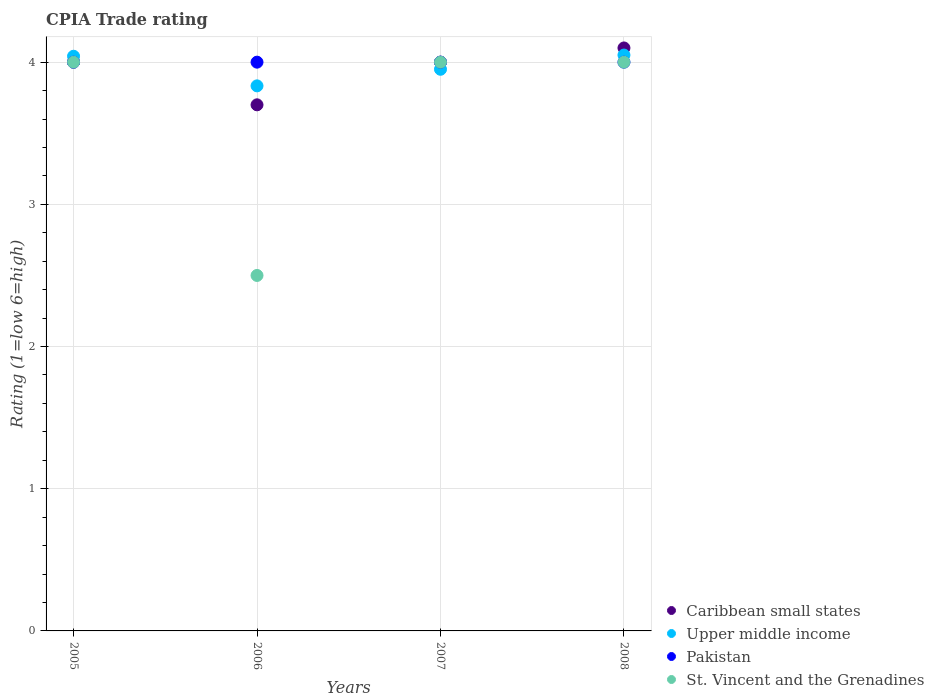How many different coloured dotlines are there?
Make the answer very short. 4. Across all years, what is the minimum CPIA rating in St. Vincent and the Grenadines?
Provide a succinct answer. 2.5. What is the total CPIA rating in Caribbean small states in the graph?
Your answer should be very brief. 15.8. What is the difference between the CPIA rating in St. Vincent and the Grenadines in 2006 and that in 2008?
Offer a very short reply. -1.5. What is the difference between the CPIA rating in Upper middle income in 2007 and the CPIA rating in St. Vincent and the Grenadines in 2008?
Your answer should be compact. -0.05. What is the average CPIA rating in St. Vincent and the Grenadines per year?
Your answer should be compact. 3.62. In the year 2006, what is the difference between the CPIA rating in Pakistan and CPIA rating in Caribbean small states?
Your response must be concise. 0.3. In how many years, is the CPIA rating in Upper middle income greater than 0.4?
Your answer should be compact. 4. Is the CPIA rating in Pakistan in 2006 less than that in 2008?
Your answer should be compact. No. What is the difference between the highest and the second highest CPIA rating in Upper middle income?
Ensure brevity in your answer.  0.01. What is the difference between the highest and the lowest CPIA rating in Caribbean small states?
Keep it short and to the point. 0.4. Is it the case that in every year, the sum of the CPIA rating in Pakistan and CPIA rating in Upper middle income  is greater than the sum of CPIA rating in St. Vincent and the Grenadines and CPIA rating in Caribbean small states?
Make the answer very short. Yes. Is it the case that in every year, the sum of the CPIA rating in Pakistan and CPIA rating in Caribbean small states  is greater than the CPIA rating in St. Vincent and the Grenadines?
Keep it short and to the point. Yes. Is the CPIA rating in St. Vincent and the Grenadines strictly greater than the CPIA rating in Caribbean small states over the years?
Your answer should be compact. No. How many dotlines are there?
Give a very brief answer. 4. How many years are there in the graph?
Offer a terse response. 4. What is the difference between two consecutive major ticks on the Y-axis?
Your answer should be very brief. 1. Are the values on the major ticks of Y-axis written in scientific E-notation?
Give a very brief answer. No. Does the graph contain any zero values?
Provide a short and direct response. No. Where does the legend appear in the graph?
Offer a terse response. Bottom right. What is the title of the graph?
Your answer should be compact. CPIA Trade rating. Does "Switzerland" appear as one of the legend labels in the graph?
Provide a succinct answer. No. What is the label or title of the X-axis?
Make the answer very short. Years. What is the Rating (1=low 6=high) of Caribbean small states in 2005?
Offer a very short reply. 4. What is the Rating (1=low 6=high) of Upper middle income in 2005?
Offer a terse response. 4.04. What is the Rating (1=low 6=high) in St. Vincent and the Grenadines in 2005?
Keep it short and to the point. 4. What is the Rating (1=low 6=high) of Caribbean small states in 2006?
Your answer should be very brief. 3.7. What is the Rating (1=low 6=high) in Upper middle income in 2006?
Provide a succinct answer. 3.83. What is the Rating (1=low 6=high) in Upper middle income in 2007?
Provide a short and direct response. 3.95. What is the Rating (1=low 6=high) in Pakistan in 2007?
Provide a succinct answer. 4. What is the Rating (1=low 6=high) of St. Vincent and the Grenadines in 2007?
Your answer should be compact. 4. What is the Rating (1=low 6=high) in Caribbean small states in 2008?
Provide a succinct answer. 4.1. What is the Rating (1=low 6=high) in Upper middle income in 2008?
Provide a short and direct response. 4.05. What is the Rating (1=low 6=high) in Pakistan in 2008?
Your response must be concise. 4. What is the Rating (1=low 6=high) in St. Vincent and the Grenadines in 2008?
Keep it short and to the point. 4. Across all years, what is the maximum Rating (1=low 6=high) in Caribbean small states?
Give a very brief answer. 4.1. Across all years, what is the maximum Rating (1=low 6=high) of Upper middle income?
Give a very brief answer. 4.05. Across all years, what is the maximum Rating (1=low 6=high) of Pakistan?
Offer a very short reply. 4. Across all years, what is the minimum Rating (1=low 6=high) in Caribbean small states?
Provide a succinct answer. 3.7. Across all years, what is the minimum Rating (1=low 6=high) in Upper middle income?
Your answer should be compact. 3.83. Across all years, what is the minimum Rating (1=low 6=high) of Pakistan?
Your response must be concise. 4. What is the total Rating (1=low 6=high) of Upper middle income in the graph?
Provide a succinct answer. 15.88. What is the total Rating (1=low 6=high) in Pakistan in the graph?
Your answer should be compact. 16. What is the difference between the Rating (1=low 6=high) in Upper middle income in 2005 and that in 2006?
Provide a short and direct response. 0.21. What is the difference between the Rating (1=low 6=high) in Pakistan in 2005 and that in 2006?
Your response must be concise. 0. What is the difference between the Rating (1=low 6=high) in Caribbean small states in 2005 and that in 2007?
Offer a very short reply. 0. What is the difference between the Rating (1=low 6=high) of Upper middle income in 2005 and that in 2007?
Provide a succinct answer. 0.09. What is the difference between the Rating (1=low 6=high) in Pakistan in 2005 and that in 2007?
Provide a succinct answer. 0. What is the difference between the Rating (1=low 6=high) of St. Vincent and the Grenadines in 2005 and that in 2007?
Your answer should be very brief. 0. What is the difference between the Rating (1=low 6=high) in Upper middle income in 2005 and that in 2008?
Provide a succinct answer. -0.01. What is the difference between the Rating (1=low 6=high) of Pakistan in 2005 and that in 2008?
Make the answer very short. 0. What is the difference between the Rating (1=low 6=high) in St. Vincent and the Grenadines in 2005 and that in 2008?
Your answer should be very brief. 0. What is the difference between the Rating (1=low 6=high) in Caribbean small states in 2006 and that in 2007?
Your answer should be very brief. -0.3. What is the difference between the Rating (1=low 6=high) of Upper middle income in 2006 and that in 2007?
Ensure brevity in your answer.  -0.12. What is the difference between the Rating (1=low 6=high) in Upper middle income in 2006 and that in 2008?
Give a very brief answer. -0.22. What is the difference between the Rating (1=low 6=high) of Pakistan in 2006 and that in 2008?
Offer a very short reply. 0. What is the difference between the Rating (1=low 6=high) in Caribbean small states in 2007 and that in 2008?
Your answer should be very brief. -0.1. What is the difference between the Rating (1=low 6=high) of Upper middle income in 2007 and that in 2008?
Your answer should be very brief. -0.1. What is the difference between the Rating (1=low 6=high) in Pakistan in 2007 and that in 2008?
Offer a terse response. 0. What is the difference between the Rating (1=low 6=high) of Caribbean small states in 2005 and the Rating (1=low 6=high) of Upper middle income in 2006?
Offer a very short reply. 0.17. What is the difference between the Rating (1=low 6=high) in Caribbean small states in 2005 and the Rating (1=low 6=high) in Pakistan in 2006?
Your answer should be very brief. 0. What is the difference between the Rating (1=low 6=high) of Upper middle income in 2005 and the Rating (1=low 6=high) of Pakistan in 2006?
Your response must be concise. 0.04. What is the difference between the Rating (1=low 6=high) in Upper middle income in 2005 and the Rating (1=low 6=high) in St. Vincent and the Grenadines in 2006?
Your answer should be compact. 1.54. What is the difference between the Rating (1=low 6=high) in Pakistan in 2005 and the Rating (1=low 6=high) in St. Vincent and the Grenadines in 2006?
Provide a succinct answer. 1.5. What is the difference between the Rating (1=low 6=high) in Caribbean small states in 2005 and the Rating (1=low 6=high) in Pakistan in 2007?
Provide a short and direct response. 0. What is the difference between the Rating (1=low 6=high) in Upper middle income in 2005 and the Rating (1=low 6=high) in Pakistan in 2007?
Your answer should be compact. 0.04. What is the difference between the Rating (1=low 6=high) in Upper middle income in 2005 and the Rating (1=low 6=high) in St. Vincent and the Grenadines in 2007?
Provide a short and direct response. 0.04. What is the difference between the Rating (1=low 6=high) of Caribbean small states in 2005 and the Rating (1=low 6=high) of Upper middle income in 2008?
Your response must be concise. -0.05. What is the difference between the Rating (1=low 6=high) in Caribbean small states in 2005 and the Rating (1=low 6=high) in Pakistan in 2008?
Offer a terse response. 0. What is the difference between the Rating (1=low 6=high) of Upper middle income in 2005 and the Rating (1=low 6=high) of Pakistan in 2008?
Ensure brevity in your answer.  0.04. What is the difference between the Rating (1=low 6=high) of Upper middle income in 2005 and the Rating (1=low 6=high) of St. Vincent and the Grenadines in 2008?
Your answer should be very brief. 0.04. What is the difference between the Rating (1=low 6=high) in Caribbean small states in 2006 and the Rating (1=low 6=high) in Pakistan in 2007?
Make the answer very short. -0.3. What is the difference between the Rating (1=low 6=high) of Upper middle income in 2006 and the Rating (1=low 6=high) of Pakistan in 2007?
Make the answer very short. -0.17. What is the difference between the Rating (1=low 6=high) in Pakistan in 2006 and the Rating (1=low 6=high) in St. Vincent and the Grenadines in 2007?
Ensure brevity in your answer.  0. What is the difference between the Rating (1=low 6=high) of Caribbean small states in 2006 and the Rating (1=low 6=high) of Upper middle income in 2008?
Ensure brevity in your answer.  -0.35. What is the difference between the Rating (1=low 6=high) in Caribbean small states in 2006 and the Rating (1=low 6=high) in Pakistan in 2008?
Your answer should be very brief. -0.3. What is the difference between the Rating (1=low 6=high) in Upper middle income in 2006 and the Rating (1=low 6=high) in St. Vincent and the Grenadines in 2008?
Your answer should be very brief. -0.17. What is the difference between the Rating (1=low 6=high) of Caribbean small states in 2007 and the Rating (1=low 6=high) of Upper middle income in 2008?
Your answer should be compact. -0.05. What is the difference between the Rating (1=low 6=high) in Caribbean small states in 2007 and the Rating (1=low 6=high) in St. Vincent and the Grenadines in 2008?
Offer a terse response. 0. What is the difference between the Rating (1=low 6=high) of Upper middle income in 2007 and the Rating (1=low 6=high) of Pakistan in 2008?
Offer a very short reply. -0.05. What is the difference between the Rating (1=low 6=high) of Upper middle income in 2007 and the Rating (1=low 6=high) of St. Vincent and the Grenadines in 2008?
Your answer should be compact. -0.05. What is the average Rating (1=low 6=high) in Caribbean small states per year?
Offer a very short reply. 3.95. What is the average Rating (1=low 6=high) in Upper middle income per year?
Keep it short and to the point. 3.97. What is the average Rating (1=low 6=high) of St. Vincent and the Grenadines per year?
Keep it short and to the point. 3.62. In the year 2005, what is the difference between the Rating (1=low 6=high) of Caribbean small states and Rating (1=low 6=high) of Upper middle income?
Offer a terse response. -0.04. In the year 2005, what is the difference between the Rating (1=low 6=high) in Caribbean small states and Rating (1=low 6=high) in Pakistan?
Provide a succinct answer. 0. In the year 2005, what is the difference between the Rating (1=low 6=high) of Caribbean small states and Rating (1=low 6=high) of St. Vincent and the Grenadines?
Keep it short and to the point. 0. In the year 2005, what is the difference between the Rating (1=low 6=high) of Upper middle income and Rating (1=low 6=high) of Pakistan?
Provide a short and direct response. 0.04. In the year 2005, what is the difference between the Rating (1=low 6=high) in Upper middle income and Rating (1=low 6=high) in St. Vincent and the Grenadines?
Your response must be concise. 0.04. In the year 2005, what is the difference between the Rating (1=low 6=high) of Pakistan and Rating (1=low 6=high) of St. Vincent and the Grenadines?
Keep it short and to the point. 0. In the year 2006, what is the difference between the Rating (1=low 6=high) in Caribbean small states and Rating (1=low 6=high) in Upper middle income?
Provide a short and direct response. -0.13. In the year 2006, what is the difference between the Rating (1=low 6=high) of Caribbean small states and Rating (1=low 6=high) of Pakistan?
Provide a short and direct response. -0.3. In the year 2006, what is the difference between the Rating (1=low 6=high) in Caribbean small states and Rating (1=low 6=high) in St. Vincent and the Grenadines?
Offer a very short reply. 1.2. In the year 2006, what is the difference between the Rating (1=low 6=high) in Upper middle income and Rating (1=low 6=high) in Pakistan?
Provide a short and direct response. -0.17. In the year 2006, what is the difference between the Rating (1=low 6=high) in Pakistan and Rating (1=low 6=high) in St. Vincent and the Grenadines?
Keep it short and to the point. 1.5. In the year 2007, what is the difference between the Rating (1=low 6=high) in Caribbean small states and Rating (1=low 6=high) in Upper middle income?
Provide a short and direct response. 0.05. In the year 2007, what is the difference between the Rating (1=low 6=high) of Pakistan and Rating (1=low 6=high) of St. Vincent and the Grenadines?
Offer a very short reply. 0. In the year 2008, what is the difference between the Rating (1=low 6=high) of Upper middle income and Rating (1=low 6=high) of St. Vincent and the Grenadines?
Offer a very short reply. 0.05. In the year 2008, what is the difference between the Rating (1=low 6=high) of Pakistan and Rating (1=low 6=high) of St. Vincent and the Grenadines?
Make the answer very short. 0. What is the ratio of the Rating (1=low 6=high) in Caribbean small states in 2005 to that in 2006?
Your answer should be compact. 1.08. What is the ratio of the Rating (1=low 6=high) in Upper middle income in 2005 to that in 2006?
Offer a terse response. 1.05. What is the ratio of the Rating (1=low 6=high) of Pakistan in 2005 to that in 2006?
Ensure brevity in your answer.  1. What is the ratio of the Rating (1=low 6=high) of St. Vincent and the Grenadines in 2005 to that in 2006?
Your answer should be compact. 1.6. What is the ratio of the Rating (1=low 6=high) in Caribbean small states in 2005 to that in 2007?
Your answer should be compact. 1. What is the ratio of the Rating (1=low 6=high) in Upper middle income in 2005 to that in 2007?
Your answer should be very brief. 1.02. What is the ratio of the Rating (1=low 6=high) of St. Vincent and the Grenadines in 2005 to that in 2007?
Your response must be concise. 1. What is the ratio of the Rating (1=low 6=high) of Caribbean small states in 2005 to that in 2008?
Provide a succinct answer. 0.98. What is the ratio of the Rating (1=low 6=high) of St. Vincent and the Grenadines in 2005 to that in 2008?
Make the answer very short. 1. What is the ratio of the Rating (1=low 6=high) in Caribbean small states in 2006 to that in 2007?
Offer a very short reply. 0.93. What is the ratio of the Rating (1=low 6=high) in Upper middle income in 2006 to that in 2007?
Your answer should be very brief. 0.97. What is the ratio of the Rating (1=low 6=high) of Caribbean small states in 2006 to that in 2008?
Give a very brief answer. 0.9. What is the ratio of the Rating (1=low 6=high) in Upper middle income in 2006 to that in 2008?
Your answer should be compact. 0.95. What is the ratio of the Rating (1=low 6=high) of Pakistan in 2006 to that in 2008?
Make the answer very short. 1. What is the ratio of the Rating (1=low 6=high) in St. Vincent and the Grenadines in 2006 to that in 2008?
Provide a short and direct response. 0.62. What is the ratio of the Rating (1=low 6=high) of Caribbean small states in 2007 to that in 2008?
Your answer should be compact. 0.98. What is the ratio of the Rating (1=low 6=high) in Upper middle income in 2007 to that in 2008?
Provide a succinct answer. 0.98. What is the ratio of the Rating (1=low 6=high) of Pakistan in 2007 to that in 2008?
Provide a short and direct response. 1. What is the difference between the highest and the second highest Rating (1=low 6=high) of Caribbean small states?
Ensure brevity in your answer.  0.1. What is the difference between the highest and the second highest Rating (1=low 6=high) of Upper middle income?
Make the answer very short. 0.01. What is the difference between the highest and the second highest Rating (1=low 6=high) in St. Vincent and the Grenadines?
Your answer should be very brief. 0. What is the difference between the highest and the lowest Rating (1=low 6=high) in Upper middle income?
Keep it short and to the point. 0.22. 